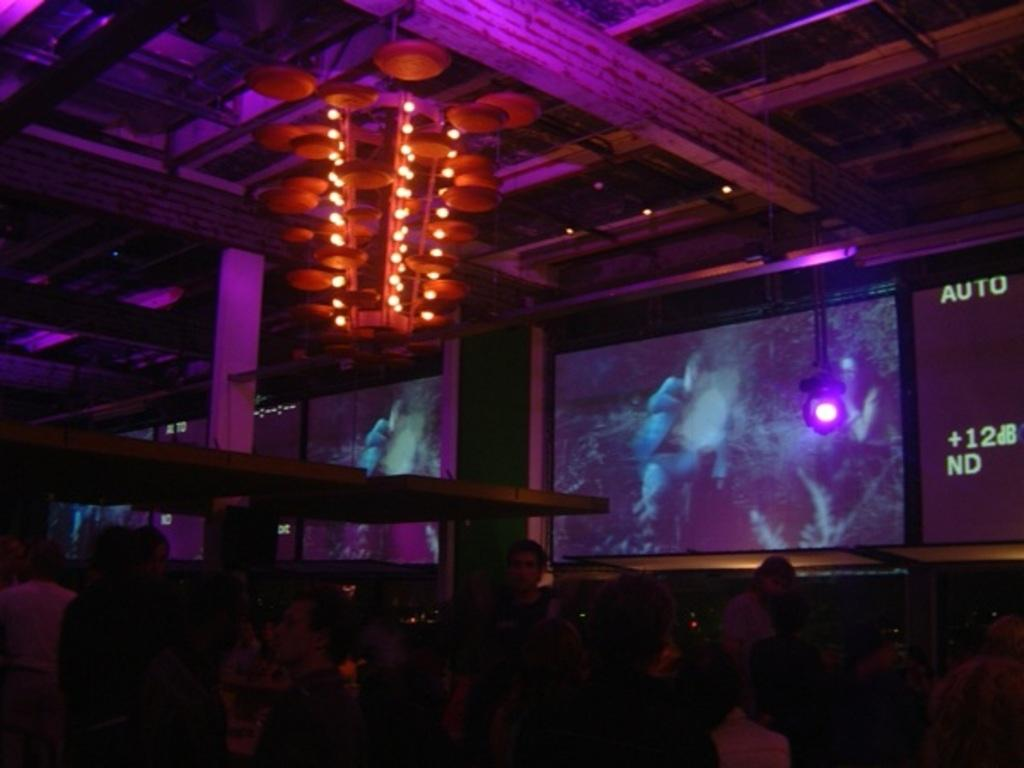How many people are in the image? There is a group of people in the image. What can be seen on the screens in the image? The facts do not specify what is on the screens, so we cannot answer that question definitively. What type of lighting is present in the image? There are lights in the image. What are the poles used for in the image? The facts do not specify the purpose of the poles, so we cannot answer that question definitively. What is hanging from the roof in the image? There is a chandelier hanging from the roof in the image. What type of attraction is the group of people visiting in the image? There is no indication in the image of what type of attraction the group of people might be visiting. How many rabbits can be seen in the image? There are no rabbits present in the image. 